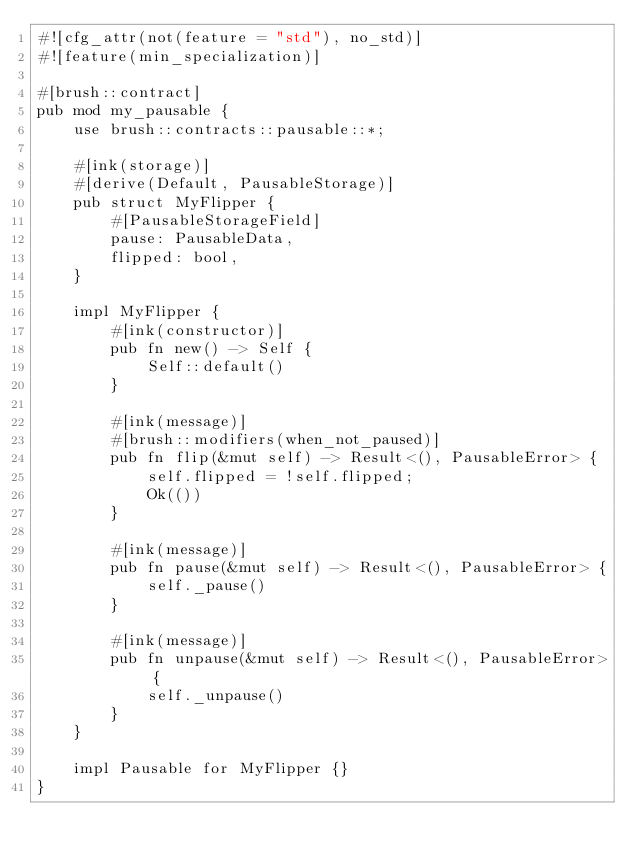Convert code to text. <code><loc_0><loc_0><loc_500><loc_500><_Rust_>#![cfg_attr(not(feature = "std"), no_std)]
#![feature(min_specialization)]

#[brush::contract]
pub mod my_pausable {
    use brush::contracts::pausable::*;

    #[ink(storage)]
    #[derive(Default, PausableStorage)]
    pub struct MyFlipper {
        #[PausableStorageField]
        pause: PausableData,
        flipped: bool,
    }

    impl MyFlipper {
        #[ink(constructor)]
        pub fn new() -> Self {
            Self::default()
        }

        #[ink(message)]
        #[brush::modifiers(when_not_paused)]
        pub fn flip(&mut self) -> Result<(), PausableError> {
            self.flipped = !self.flipped;
            Ok(())
        }

        #[ink(message)]
        pub fn pause(&mut self) -> Result<(), PausableError> {
            self._pause()
        }

        #[ink(message)]
        pub fn unpause(&mut self) -> Result<(), PausableError> {
            self._unpause()
        }
    }

    impl Pausable for MyFlipper {}
}
</code> 